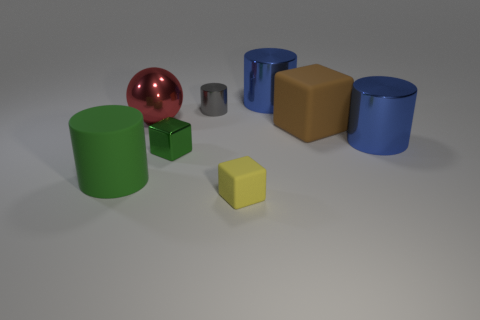Subtract all small gray shiny cylinders. How many cylinders are left? 3 Subtract all red spheres. How many blue cylinders are left? 2 Subtract all yellow blocks. How many blocks are left? 2 Subtract all blocks. How many objects are left? 5 Add 2 big blue metallic blocks. How many objects exist? 10 Subtract all gray cylinders. Subtract all small shiny cylinders. How many objects are left? 6 Add 8 yellow cubes. How many yellow cubes are left? 9 Add 8 blue metal cylinders. How many blue metal cylinders exist? 10 Subtract 0 cyan cylinders. How many objects are left? 8 Subtract all red cubes. Subtract all blue cylinders. How many cubes are left? 3 